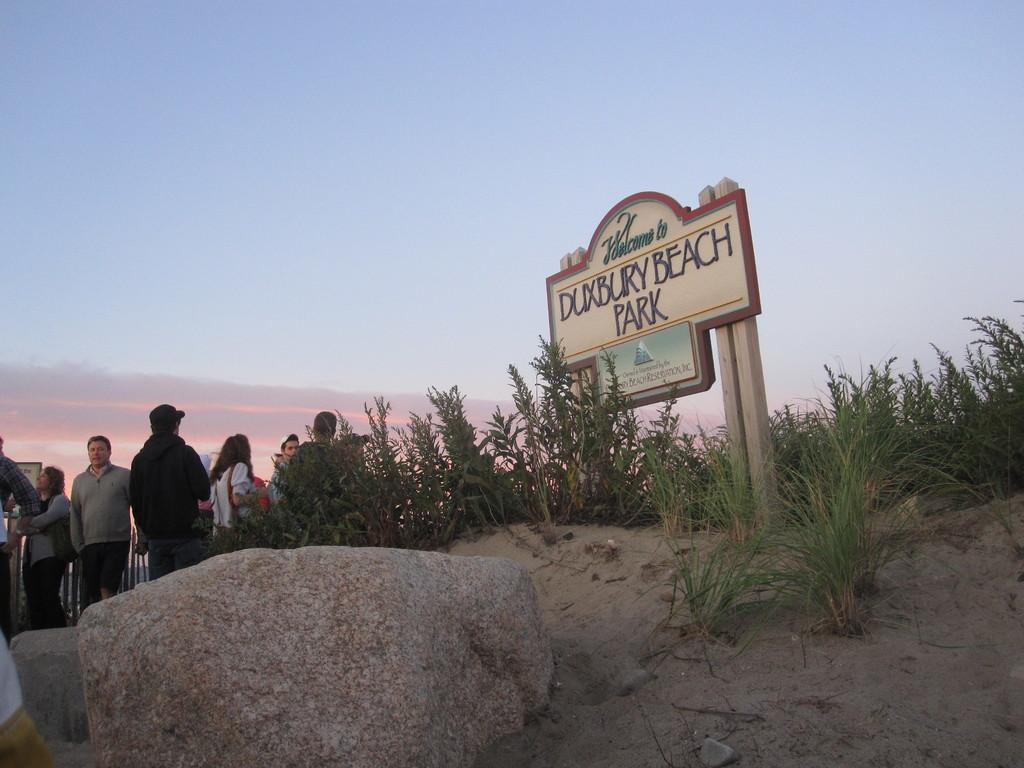What type of terrain is visible on the path in the image? The path in the image has rocks, sand, and grass. Can you describe the people visible in the image? There are people visible in the image, but their specific actions or characteristics are not mentioned in the facts. What is located on the left side of the image? There are plants on the left side of the image. What is the board attached to in the image? The board is attached to wooden objects in the image. How would you describe the weather in the image? The sky is cloudy in the image, which suggests a partly cloudy or overcast day. What type of toothbrush can be seen in the image? There is no toothbrush present in the image. What color are the teeth of the person in the image? There is no person's teeth visible in the image. What is the person in the image writing with? There is no person writing anything in the image, and no pen is mentioned in the facts. 